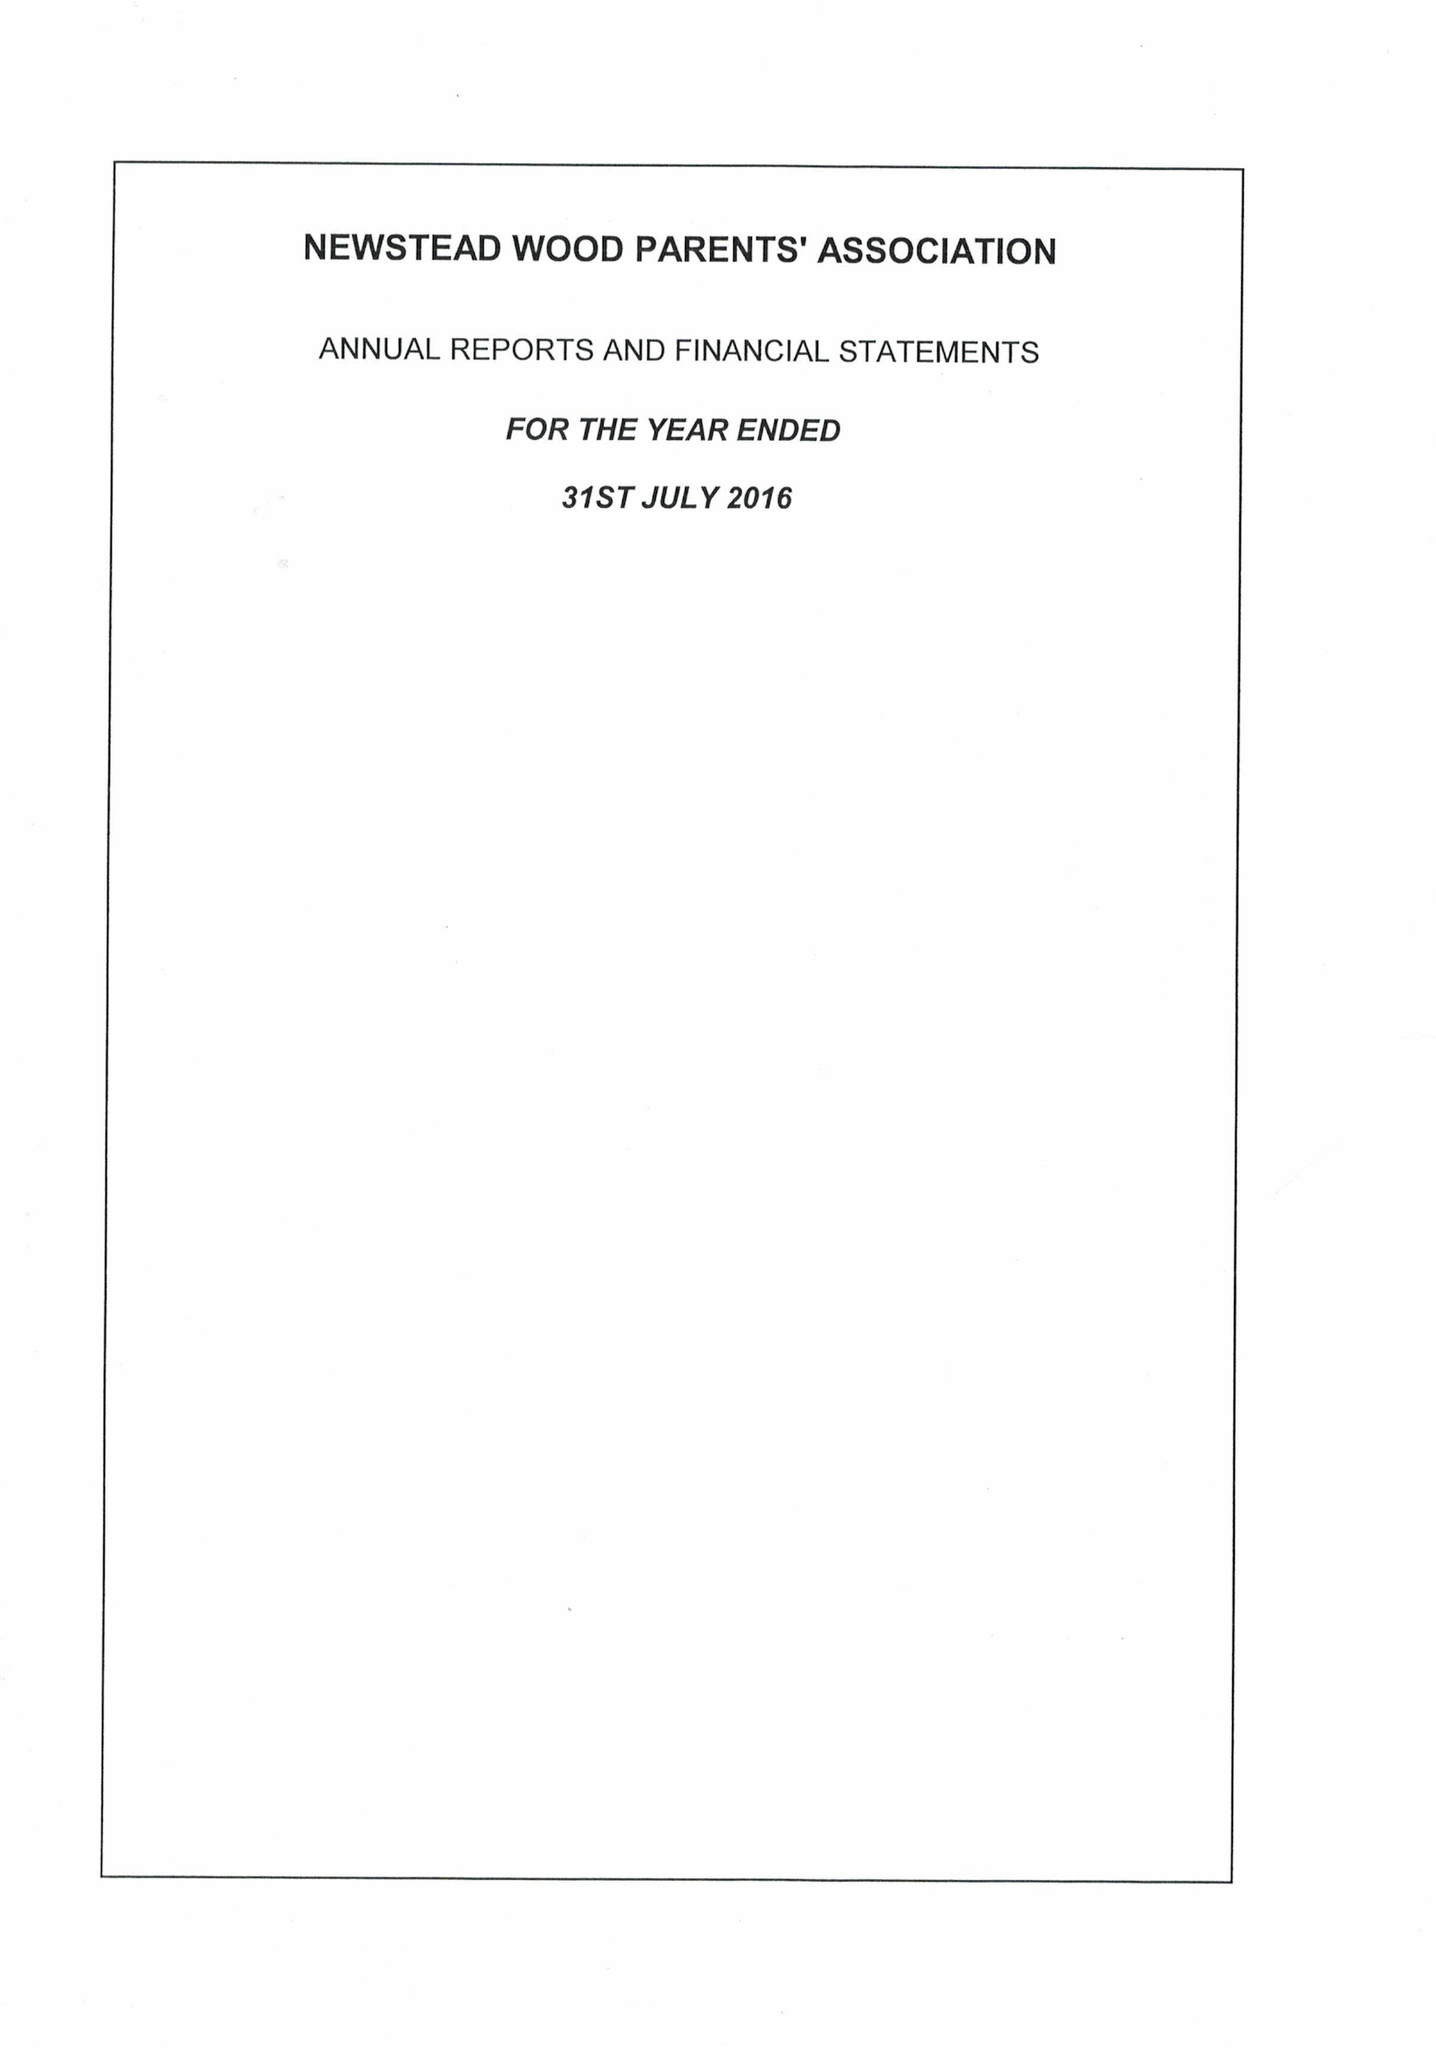What is the value for the address__post_town?
Answer the question using a single word or phrase. CHISLEHURST 